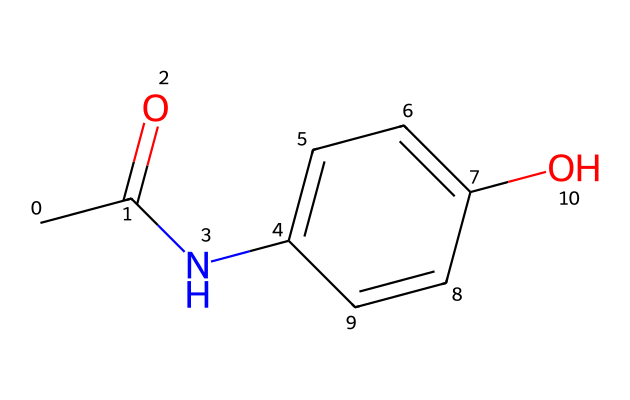What is the molecular formula of this compound? By analyzing the SMILES representation, the molecular formula can be determined by counting each type of atom present: There are 8 carbon (C) atoms, 9 hydrogen (H) atoms, 1 nitrogen (N) atom, and 3 oxygen (O) atoms, leading to the formula C8H9NO3.
Answer: C8H9NO3 How many rings are present in the structure? The SMILES code indicates a cyclic structure, specifically with the "C1" and "C=C" notation indicating a benzene ring. There is one cycle that can be identified in this molecule.
Answer: 1 What functional groups are present in this molecule? Looking at the chemical structure, we can recognize multiple functional groups: the hydroxyl group (-OH), an amide group (-C(=O)N-), and a carbonyl group (C=O). This highlights its complexity in functionality.
Answer: hydroxyl, amide, carbonyl Is acetaminophen a polar or non-polar compound? Acetaminophen contains polar functional groups, such as the hydroxyl (-OH) and amide (-C(=O)N-) groups, which enhance its overall polarity compared to non-polar structures.
Answer: polar What type of solvent is best for dissolving acetaminophen? Given that acetaminophen is a polar compound, polar solvents like water would be more effective for dissolving it. This is due to the compatible interactions between polar molecules.
Answer: water Does this compound participate in hydrogen bonding? The presence of both hydroxyl and amide functional groups allows acetaminophen to form hydrogen bonds with other polar molecules, indicative of its ability to engage in such interactions.
Answer: yes 